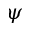Convert formula to latex. <formula><loc_0><loc_0><loc_500><loc_500>\psi</formula> 